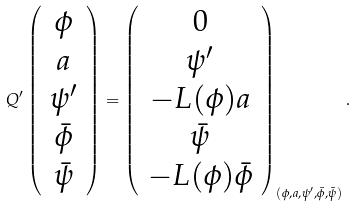<formula> <loc_0><loc_0><loc_500><loc_500>Q ^ { \prime } \left ( \begin{array} { c } \phi \\ a \\ \psi ^ { \prime } \\ \bar { \phi } \\ \bar { \psi } \end{array} \right ) = \left ( \begin{array} { c } 0 \\ \psi ^ { \prime } \\ - L ( \phi ) a \\ \bar { \psi } \\ - L ( \phi ) \bar { \phi } \end{array} \right ) _ { ( \phi , a , \psi ^ { \prime } , \bar { \phi } , \bar { \psi } ) } .</formula> 